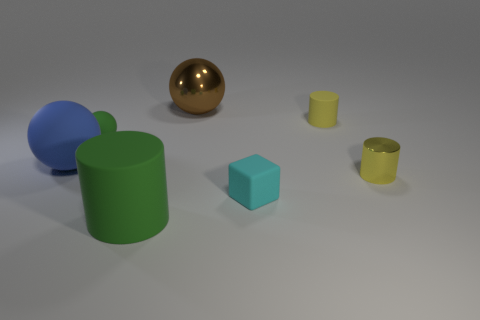There is another big thing that is the same shape as the big brown metallic thing; what is it made of?
Ensure brevity in your answer.  Rubber. Are there any other things that are made of the same material as the big green object?
Make the answer very short. Yes. What number of other objects are the same shape as the small metal object?
Offer a terse response. 2. How many large cylinders are on the left side of the large ball that is on the left side of the large thing on the right side of the green matte cylinder?
Your answer should be very brief. 0. What number of small cyan objects have the same shape as the large brown shiny object?
Ensure brevity in your answer.  0. Do the matte ball that is behind the blue ball and the large shiny object have the same color?
Make the answer very short. No. There is a large rubber object in front of the small yellow object that is to the right of the small yellow object behind the small green rubber object; what shape is it?
Offer a very short reply. Cylinder. Do the brown shiny object and the shiny object right of the brown ball have the same size?
Keep it short and to the point. No. Are there any purple objects that have the same size as the blue object?
Give a very brief answer. No. How many other objects are the same material as the large green object?
Your answer should be very brief. 4. 